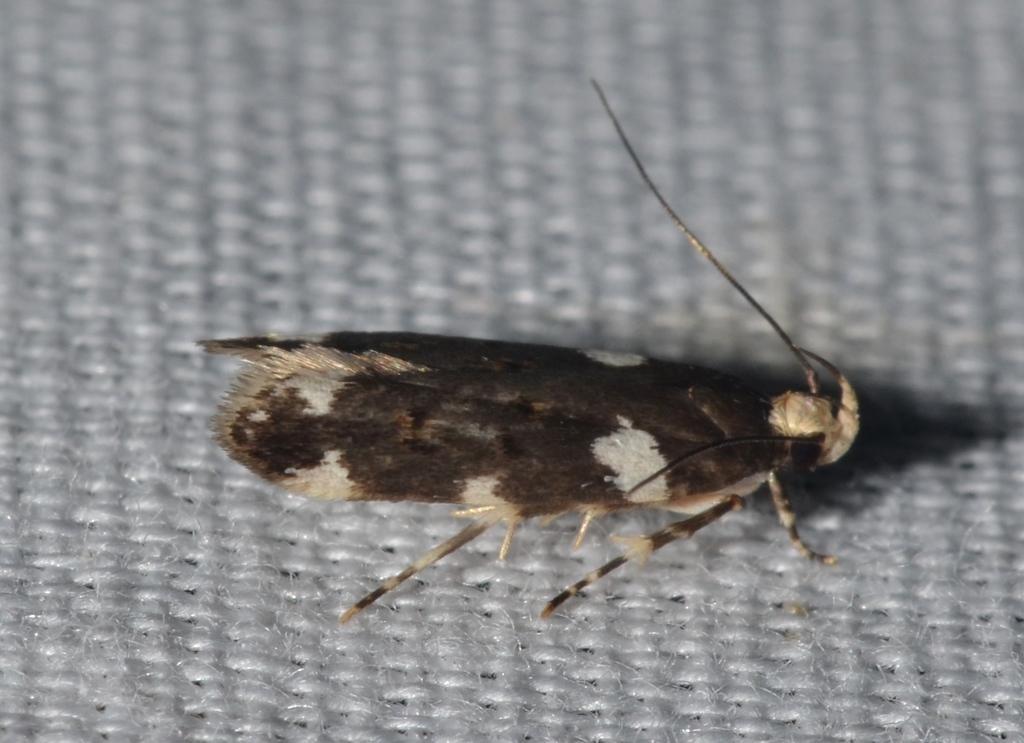How would you summarize this image in a sentence or two? In the center of the image there is a insect on the carpet. 